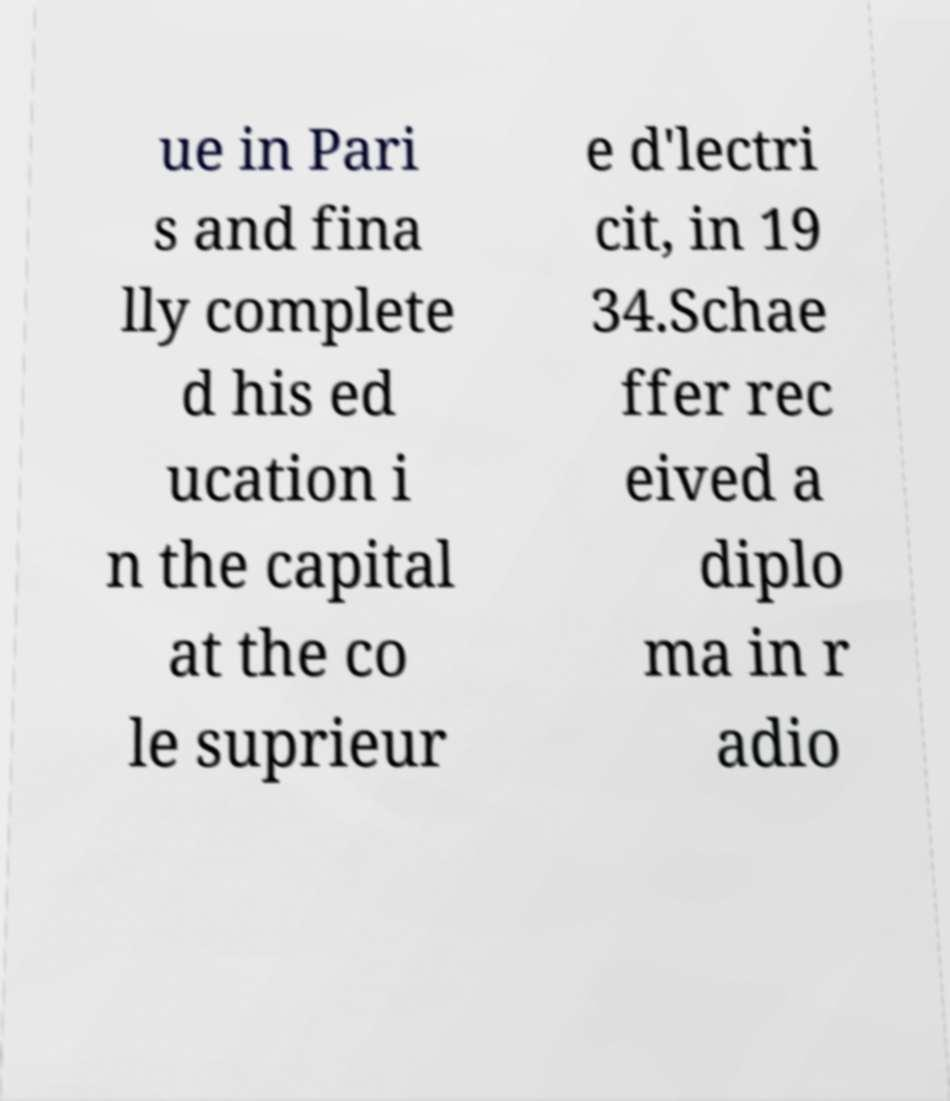Can you read and provide the text displayed in the image?This photo seems to have some interesting text. Can you extract and type it out for me? ue in Pari s and fina lly complete d his ed ucation i n the capital at the co le suprieur e d'lectri cit, in 19 34.Schae ffer rec eived a diplo ma in r adio 